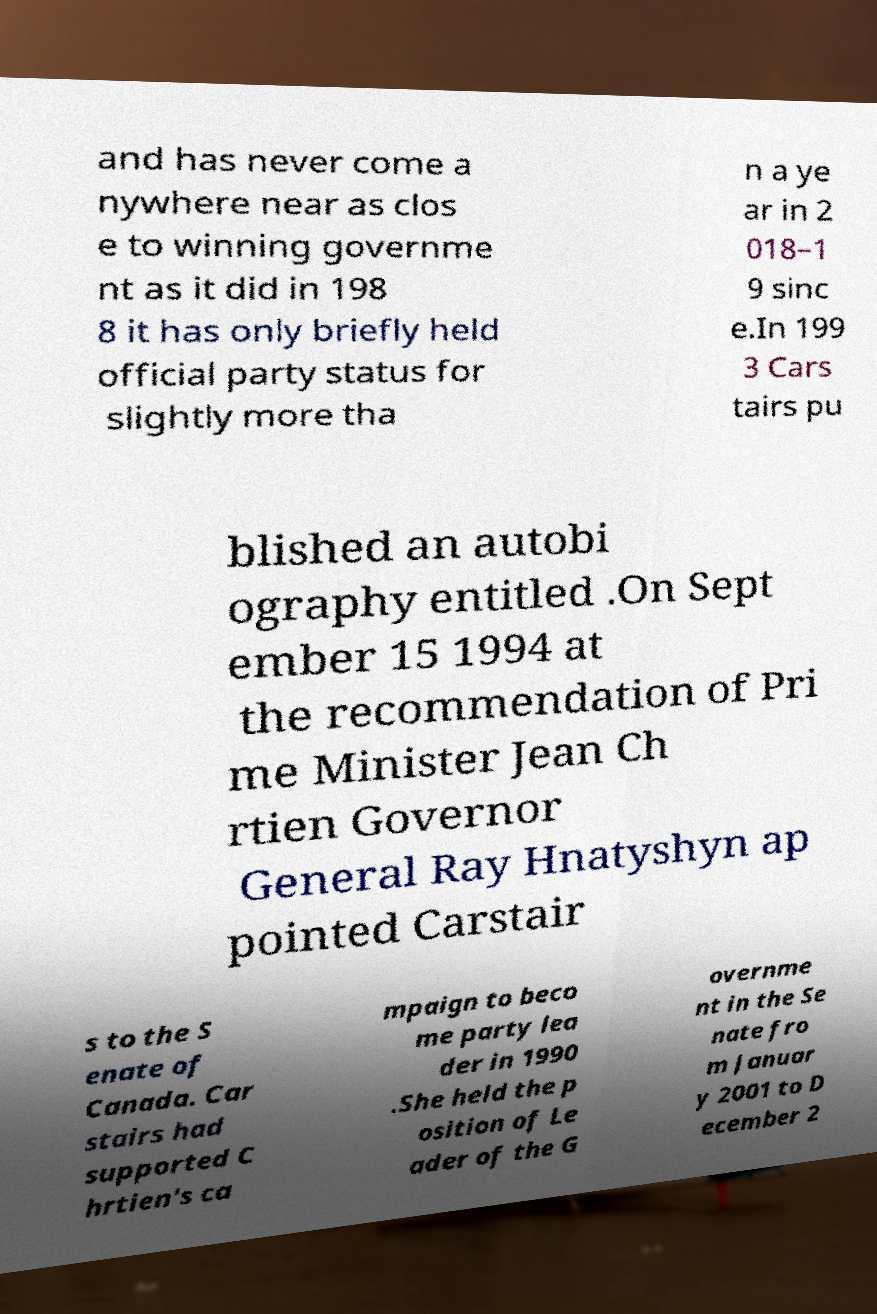Could you extract and type out the text from this image? and has never come a nywhere near as clos e to winning governme nt as it did in 198 8 it has only briefly held official party status for slightly more tha n a ye ar in 2 018–1 9 sinc e.In 199 3 Cars tairs pu blished an autobi ography entitled .On Sept ember 15 1994 at the recommendation of Pri me Minister Jean Ch rtien Governor General Ray Hnatyshyn ap pointed Carstair s to the S enate of Canada. Car stairs had supported C hrtien's ca mpaign to beco me party lea der in 1990 .She held the p osition of Le ader of the G overnme nt in the Se nate fro m Januar y 2001 to D ecember 2 